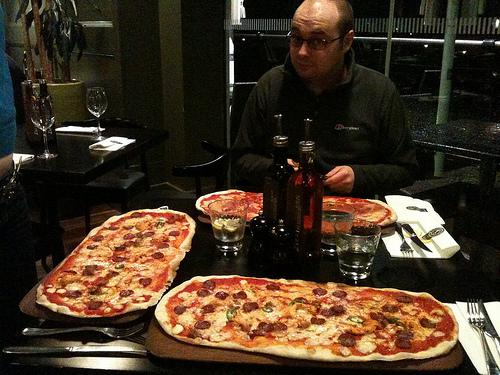Question: who is sitting at the table?
Choices:
A. A woman.
B. A man.
C. A child.
D. A family.
Answer with the letter. Answer: B Question: where are the wine bottles?
Choices:
A. In the wine cabinet.
B. On the table.
C. In the trash.
D. On the counter.
Answer with the letter. Answer: B Question: what is the man wearing on his face?
Choices:
A. A pair of glasses.
B. Face paint.
C. Makeup.
D. A mask.
Answer with the letter. Answer: A Question: how many glasses are on the table at which the man is sitting?
Choices:
A. One.
B. Two.
C. None.
D. Three.
Answer with the letter. Answer: D Question: how many pizzas are on the table?
Choices:
A. Two.
B. One.
C. None.
D. Three.
Answer with the letter. Answer: D 